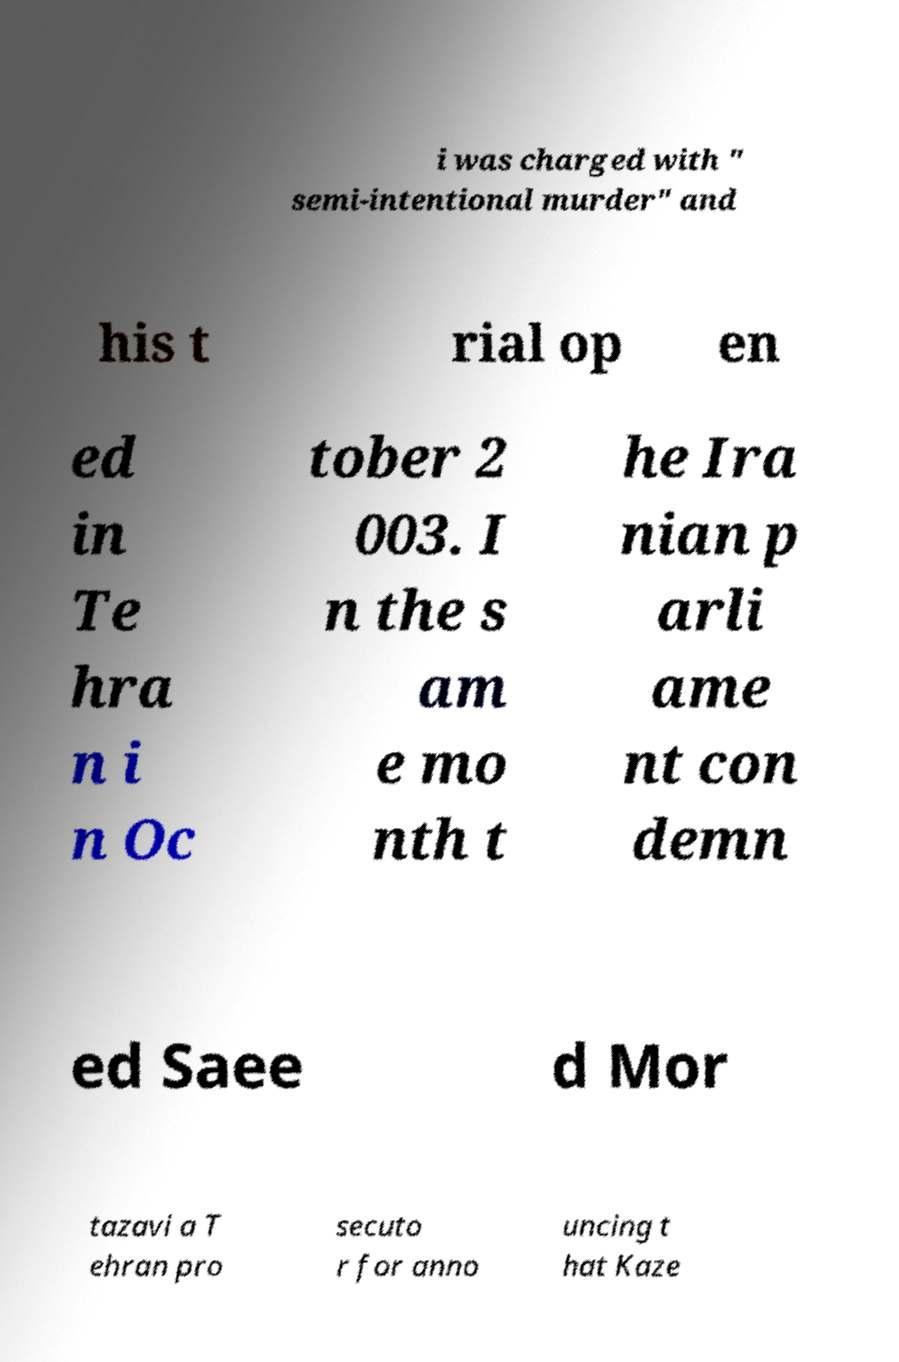Can you read and provide the text displayed in the image?This photo seems to have some interesting text. Can you extract and type it out for me? i was charged with " semi-intentional murder" and his t rial op en ed in Te hra n i n Oc tober 2 003. I n the s am e mo nth t he Ira nian p arli ame nt con demn ed Saee d Mor tazavi a T ehran pro secuto r for anno uncing t hat Kaze 